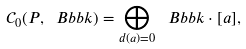Convert formula to latex. <formula><loc_0><loc_0><loc_500><loc_500>\mathcal { C } _ { 0 } ( P , \ B b b k ) = \bigoplus _ { d ( a ) = 0 } \ B b b k \cdot [ a ] ,</formula> 